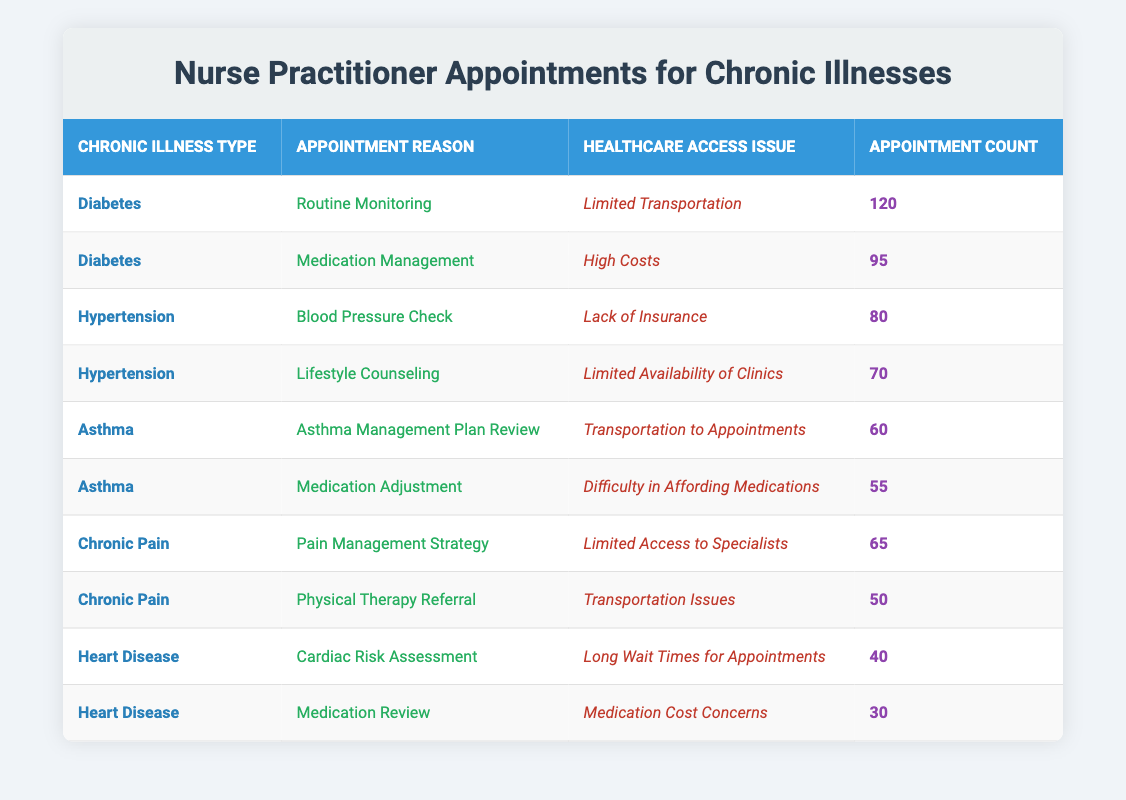What is the highest appointment count for any reason related to diabetes? From the table, the appointment reasons related to diabetes are "Routine Monitoring" with a count of 120 and "Medication Management" with a count of 95. The highest among these is 120 for "Routine Monitoring".
Answer: 120 What healthcare access issue is associated with the appointment reason "Blood Pressure Check"? The appointment reason "Blood Pressure Check" is listed under the chronic illness type of Hypertension and has a healthcare access issue of "Lack of Insurance".
Answer: Lack of Insurance How many total appointments related to asthma are recorded in the table? The appointment reasons related to asthma are "Asthma Management Plan Review" (60) and "Medication Adjustment" (55). Summing these gives 60 + 55 = 115.
Answer: 115 Is transportation an issue for all asthma-related appointments? The first asthma appointment is for "Asthma Management Plan Review" which mentions "Transportation to Appointments" as the access issue, while the second reason "Medication Adjustment" has an access issue of "Difficulty in Affording Medications". Therefore, transportation is not an issue for both.
Answer: No Which chronic illness has the lowest appointment count and what is the reason? Looking through the table, the chronic illness with the lowest appointment count is "Heart Disease" with "Medication Review" noted at 30 appointments. Therefore, it is the specific reason noted with the lowest count.
Answer: 30 for Medication Review What is the total appointment count for chronic pain-related appointments? There are two appointment reasons for chronic pain: "Pain Management Strategy" with 65 appointments and "Physical Therapy Referral" with 50 appointments. Adding these gives a total of 65 + 50 = 115.
Answer: 115 Are there more appointment counts for medication management issues related to diabetes than for access issues related to heart disease? The appointment count for diabetes under medication management is 95 ("Medication Management") while for heart disease, the counts are 40 ("Cardiac Risk Assessment") and 30 ("Medication Review"). Thus 95 > (40 + 30), confirming more appointments for diabetes.
Answer: Yes Which healthcare access issue has the least associated appointment counts of the listed reasons? The lowest appointment count is for "Medication Review" under heart disease at 30, which corresponds to "Medication Cost Concerns." It is examined and compared with all other issues listed, confirming it as least.
Answer: Medication Cost Concerns 